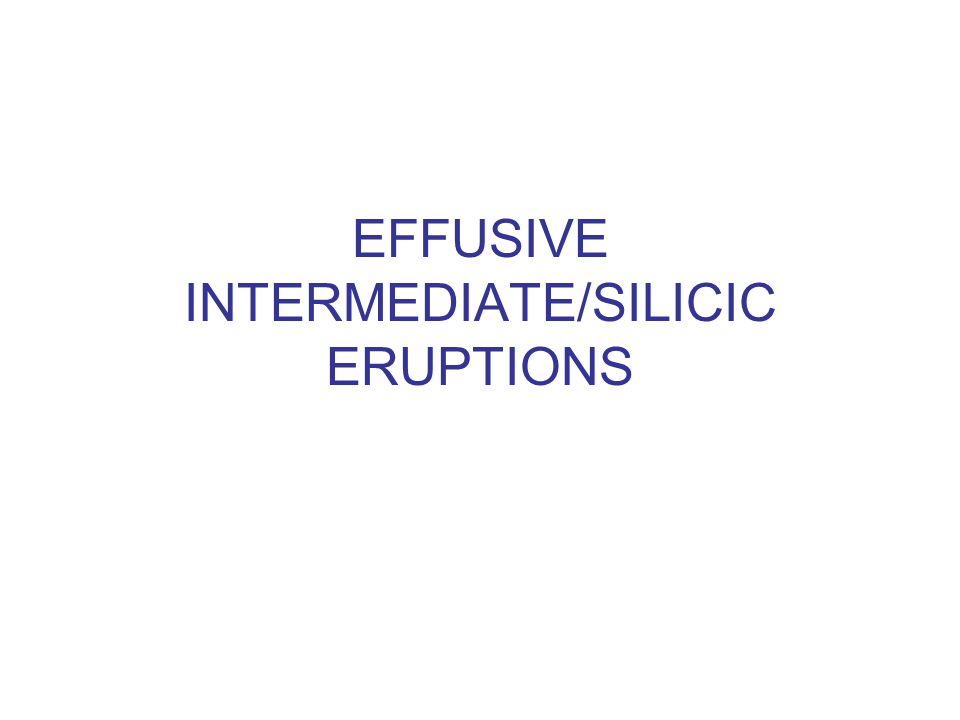Could the text refer to a classification within a scientific field, and if so, what field might that be? Based solely on the image, the text seems to refer to a classification within the field of geology or volcanology. The terms "effusive," "intermediate," "silicic," and "eruptions" are commonly used to describe types of volcanic eruptions and the composition of lava. "Effusive" refers to the flow of lava as opposed to explosive eruptions, while "intermediate" and "silicic" describe the silica content of the lava, which affects its viscosity and eruption style. Therefore, the image likely pertains to the study of volcanoes and their eruptions. 